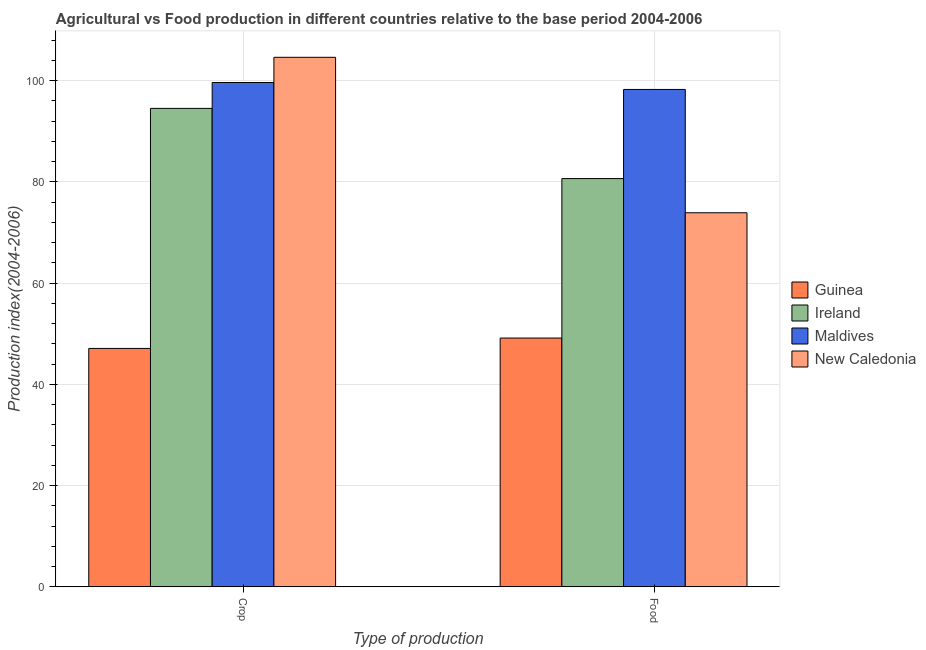How many different coloured bars are there?
Your answer should be compact. 4. Are the number of bars per tick equal to the number of legend labels?
Give a very brief answer. Yes. How many bars are there on the 1st tick from the right?
Offer a terse response. 4. What is the label of the 2nd group of bars from the left?
Offer a terse response. Food. What is the crop production index in Ireland?
Provide a short and direct response. 94.5. Across all countries, what is the maximum food production index?
Offer a very short reply. 98.24. Across all countries, what is the minimum food production index?
Make the answer very short. 49.13. In which country was the crop production index maximum?
Provide a short and direct response. New Caledonia. In which country was the food production index minimum?
Provide a succinct answer. Guinea. What is the total food production index in the graph?
Your answer should be very brief. 301.88. What is the difference between the food production index in Maldives and that in Ireland?
Offer a terse response. 17.61. What is the difference between the crop production index in New Caledonia and the food production index in Guinea?
Keep it short and to the point. 55.46. What is the average crop production index per country?
Your response must be concise. 86.44. What is the difference between the crop production index and food production index in Ireland?
Provide a succinct answer. 13.87. In how many countries, is the crop production index greater than 100 ?
Give a very brief answer. 1. What is the ratio of the food production index in Guinea to that in Maldives?
Offer a terse response. 0.5. In how many countries, is the food production index greater than the average food production index taken over all countries?
Your response must be concise. 2. What does the 3rd bar from the left in Food represents?
Provide a short and direct response. Maldives. What does the 4th bar from the right in Crop represents?
Provide a short and direct response. Guinea. How many countries are there in the graph?
Your answer should be very brief. 4. Does the graph contain any zero values?
Give a very brief answer. No. Does the graph contain grids?
Ensure brevity in your answer.  Yes. Where does the legend appear in the graph?
Your response must be concise. Center right. How are the legend labels stacked?
Provide a short and direct response. Vertical. What is the title of the graph?
Offer a terse response. Agricultural vs Food production in different countries relative to the base period 2004-2006. What is the label or title of the X-axis?
Provide a short and direct response. Type of production. What is the label or title of the Y-axis?
Your response must be concise. Production index(2004-2006). What is the Production index(2004-2006) of Guinea in Crop?
Make the answer very short. 47.08. What is the Production index(2004-2006) in Ireland in Crop?
Give a very brief answer. 94.5. What is the Production index(2004-2006) of Maldives in Crop?
Make the answer very short. 99.61. What is the Production index(2004-2006) in New Caledonia in Crop?
Your response must be concise. 104.59. What is the Production index(2004-2006) in Guinea in Food?
Your response must be concise. 49.13. What is the Production index(2004-2006) in Ireland in Food?
Make the answer very short. 80.63. What is the Production index(2004-2006) in Maldives in Food?
Provide a succinct answer. 98.24. What is the Production index(2004-2006) in New Caledonia in Food?
Ensure brevity in your answer.  73.88. Across all Type of production, what is the maximum Production index(2004-2006) in Guinea?
Your answer should be compact. 49.13. Across all Type of production, what is the maximum Production index(2004-2006) in Ireland?
Your answer should be very brief. 94.5. Across all Type of production, what is the maximum Production index(2004-2006) in Maldives?
Your answer should be compact. 99.61. Across all Type of production, what is the maximum Production index(2004-2006) of New Caledonia?
Provide a short and direct response. 104.59. Across all Type of production, what is the minimum Production index(2004-2006) in Guinea?
Your answer should be very brief. 47.08. Across all Type of production, what is the minimum Production index(2004-2006) of Ireland?
Provide a short and direct response. 80.63. Across all Type of production, what is the minimum Production index(2004-2006) of Maldives?
Ensure brevity in your answer.  98.24. Across all Type of production, what is the minimum Production index(2004-2006) in New Caledonia?
Your response must be concise. 73.88. What is the total Production index(2004-2006) of Guinea in the graph?
Your response must be concise. 96.21. What is the total Production index(2004-2006) of Ireland in the graph?
Ensure brevity in your answer.  175.13. What is the total Production index(2004-2006) in Maldives in the graph?
Offer a very short reply. 197.85. What is the total Production index(2004-2006) in New Caledonia in the graph?
Provide a short and direct response. 178.47. What is the difference between the Production index(2004-2006) of Guinea in Crop and that in Food?
Give a very brief answer. -2.05. What is the difference between the Production index(2004-2006) in Ireland in Crop and that in Food?
Provide a short and direct response. 13.87. What is the difference between the Production index(2004-2006) in Maldives in Crop and that in Food?
Provide a short and direct response. 1.37. What is the difference between the Production index(2004-2006) in New Caledonia in Crop and that in Food?
Offer a very short reply. 30.71. What is the difference between the Production index(2004-2006) of Guinea in Crop and the Production index(2004-2006) of Ireland in Food?
Offer a terse response. -33.55. What is the difference between the Production index(2004-2006) in Guinea in Crop and the Production index(2004-2006) in Maldives in Food?
Make the answer very short. -51.16. What is the difference between the Production index(2004-2006) of Guinea in Crop and the Production index(2004-2006) of New Caledonia in Food?
Ensure brevity in your answer.  -26.8. What is the difference between the Production index(2004-2006) in Ireland in Crop and the Production index(2004-2006) in Maldives in Food?
Provide a succinct answer. -3.74. What is the difference between the Production index(2004-2006) of Ireland in Crop and the Production index(2004-2006) of New Caledonia in Food?
Give a very brief answer. 20.62. What is the difference between the Production index(2004-2006) of Maldives in Crop and the Production index(2004-2006) of New Caledonia in Food?
Give a very brief answer. 25.73. What is the average Production index(2004-2006) in Guinea per Type of production?
Give a very brief answer. 48.1. What is the average Production index(2004-2006) of Ireland per Type of production?
Give a very brief answer. 87.56. What is the average Production index(2004-2006) of Maldives per Type of production?
Provide a short and direct response. 98.92. What is the average Production index(2004-2006) in New Caledonia per Type of production?
Your answer should be very brief. 89.23. What is the difference between the Production index(2004-2006) of Guinea and Production index(2004-2006) of Ireland in Crop?
Offer a very short reply. -47.42. What is the difference between the Production index(2004-2006) of Guinea and Production index(2004-2006) of Maldives in Crop?
Keep it short and to the point. -52.53. What is the difference between the Production index(2004-2006) in Guinea and Production index(2004-2006) in New Caledonia in Crop?
Your answer should be compact. -57.51. What is the difference between the Production index(2004-2006) in Ireland and Production index(2004-2006) in Maldives in Crop?
Keep it short and to the point. -5.11. What is the difference between the Production index(2004-2006) in Ireland and Production index(2004-2006) in New Caledonia in Crop?
Provide a succinct answer. -10.09. What is the difference between the Production index(2004-2006) of Maldives and Production index(2004-2006) of New Caledonia in Crop?
Your answer should be very brief. -4.98. What is the difference between the Production index(2004-2006) in Guinea and Production index(2004-2006) in Ireland in Food?
Keep it short and to the point. -31.5. What is the difference between the Production index(2004-2006) in Guinea and Production index(2004-2006) in Maldives in Food?
Provide a short and direct response. -49.11. What is the difference between the Production index(2004-2006) in Guinea and Production index(2004-2006) in New Caledonia in Food?
Give a very brief answer. -24.75. What is the difference between the Production index(2004-2006) of Ireland and Production index(2004-2006) of Maldives in Food?
Ensure brevity in your answer.  -17.61. What is the difference between the Production index(2004-2006) of Ireland and Production index(2004-2006) of New Caledonia in Food?
Your answer should be compact. 6.75. What is the difference between the Production index(2004-2006) in Maldives and Production index(2004-2006) in New Caledonia in Food?
Your answer should be very brief. 24.36. What is the ratio of the Production index(2004-2006) of Ireland in Crop to that in Food?
Offer a very short reply. 1.17. What is the ratio of the Production index(2004-2006) of Maldives in Crop to that in Food?
Give a very brief answer. 1.01. What is the ratio of the Production index(2004-2006) in New Caledonia in Crop to that in Food?
Your response must be concise. 1.42. What is the difference between the highest and the second highest Production index(2004-2006) in Guinea?
Your response must be concise. 2.05. What is the difference between the highest and the second highest Production index(2004-2006) in Ireland?
Keep it short and to the point. 13.87. What is the difference between the highest and the second highest Production index(2004-2006) of Maldives?
Keep it short and to the point. 1.37. What is the difference between the highest and the second highest Production index(2004-2006) in New Caledonia?
Keep it short and to the point. 30.71. What is the difference between the highest and the lowest Production index(2004-2006) in Guinea?
Offer a very short reply. 2.05. What is the difference between the highest and the lowest Production index(2004-2006) of Ireland?
Ensure brevity in your answer.  13.87. What is the difference between the highest and the lowest Production index(2004-2006) of Maldives?
Provide a succinct answer. 1.37. What is the difference between the highest and the lowest Production index(2004-2006) of New Caledonia?
Provide a short and direct response. 30.71. 